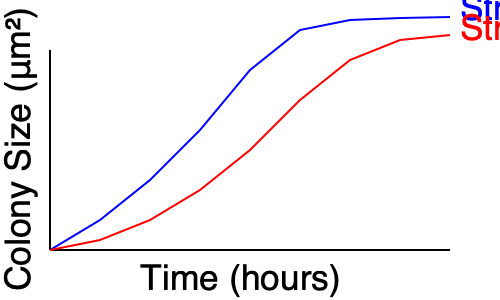Based on the time-lapse microscopy data shown in the graph, which bacterial strain exhibits a more pronounced exponential growth phase, and at approximately what time point does this strain transition into the stationary phase? Explain your reasoning using the principles of bacterial growth kinetics. To analyze the growth patterns and identify the exponential and stationary phases, we need to follow these steps:

1. Examine the growth curves:
   - Blue curve (Strain A): Shows rapid initial growth followed by a plateau.
   - Red curve (Strain B): Displays a more gradual increase over time.

2. Identify exponential growth:
   - Exponential growth is characterized by a steep, curved increase in population size.
   - Strain A exhibits a more pronounced exponential phase from approximately 0 to 12 hours.
   - Strain B shows a less steep, more extended period of growth.

3. Recognize the stationary phase:
   - The stationary phase is indicated by a plateau in the growth curve.
   - Strain A reaches a plateau around the 14-16 hour mark.
   - Strain B does not clearly reach a stationary phase within the time frame shown.

4. Compare growth rates:
   - The steeper slope of Strain A's curve during the first 12 hours indicates a higher growth rate.
   - This rapid growth is characteristic of a more pronounced exponential phase.

5. Transition to stationary phase:
   - For Strain A, the curve begins to level off around 14 hours, indicating the transition to stationary phase.
   - This transition is likely due to nutrient depletion or accumulation of waste products.

6. Mathematical representation:
   - During exponential growth, the population size ($N$) can be modeled by the equation:
     $N = N_0 \cdot e^{rt}$
   where $N_0$ is the initial population, $r$ is the growth rate, and $t$ is time.
   - The steeper exponential curve of Strain A suggests a higher $r$ value.

Based on this analysis, Strain A exhibits a more pronounced exponential growth phase and transitions into the stationary phase at approximately 14 hours.
Answer: Strain A; approximately 14 hours 